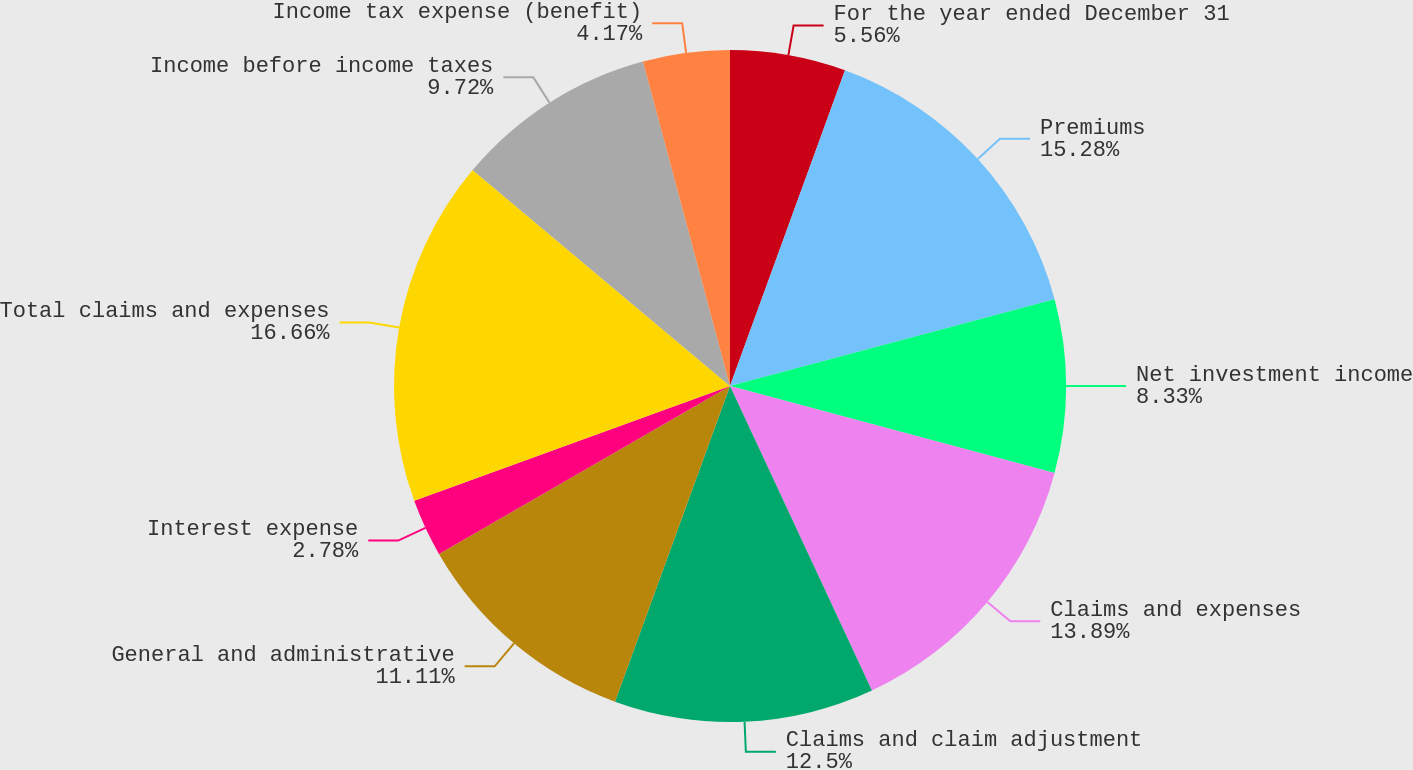<chart> <loc_0><loc_0><loc_500><loc_500><pie_chart><fcel>For the year ended December 31<fcel>Premiums<fcel>Net investment income<fcel>Claims and expenses<fcel>Claims and claim adjustment<fcel>General and administrative<fcel>Interest expense<fcel>Total claims and expenses<fcel>Income before income taxes<fcel>Income tax expense (benefit)<nl><fcel>5.56%<fcel>15.28%<fcel>8.33%<fcel>13.89%<fcel>12.5%<fcel>11.11%<fcel>2.78%<fcel>16.66%<fcel>9.72%<fcel>4.17%<nl></chart> 